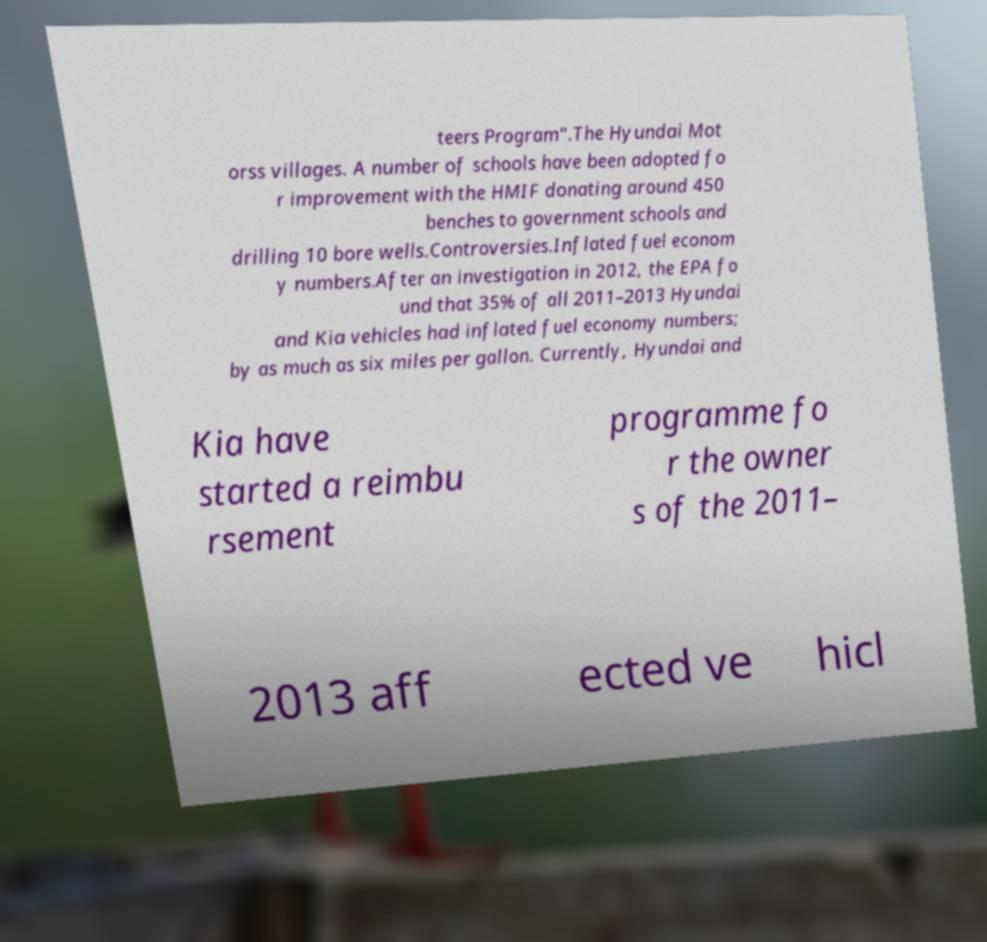Could you extract and type out the text from this image? teers Program".The Hyundai Mot orss villages. A number of schools have been adopted fo r improvement with the HMIF donating around 450 benches to government schools and drilling 10 bore wells.Controversies.Inflated fuel econom y numbers.After an investigation in 2012, the EPA fo und that 35% of all 2011–2013 Hyundai and Kia vehicles had inflated fuel economy numbers; by as much as six miles per gallon. Currently, Hyundai and Kia have started a reimbu rsement programme fo r the owner s of the 2011– 2013 aff ected ve hicl 